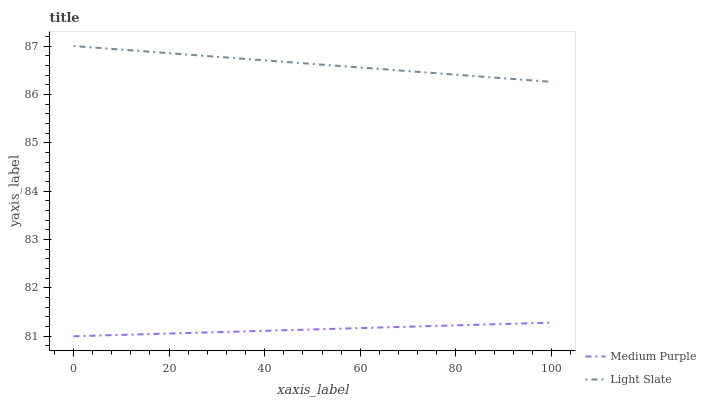Does Medium Purple have the minimum area under the curve?
Answer yes or no. Yes. Does Light Slate have the maximum area under the curve?
Answer yes or no. Yes. Does Light Slate have the minimum area under the curve?
Answer yes or no. No. Is Light Slate the smoothest?
Answer yes or no. Yes. Is Medium Purple the roughest?
Answer yes or no. Yes. Is Light Slate the roughest?
Answer yes or no. No. Does Light Slate have the lowest value?
Answer yes or no. No. Does Light Slate have the highest value?
Answer yes or no. Yes. Is Medium Purple less than Light Slate?
Answer yes or no. Yes. Is Light Slate greater than Medium Purple?
Answer yes or no. Yes. Does Medium Purple intersect Light Slate?
Answer yes or no. No. 